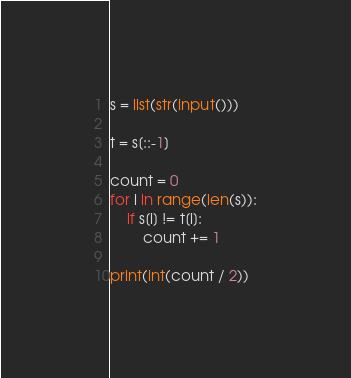<code> <loc_0><loc_0><loc_500><loc_500><_Python_>s = list(str(input()))

t = s[::-1]

count = 0
for i in range(len(s)):
    if s[i] != t[i]:
        count += 1

print(int(count / 2))
</code> 